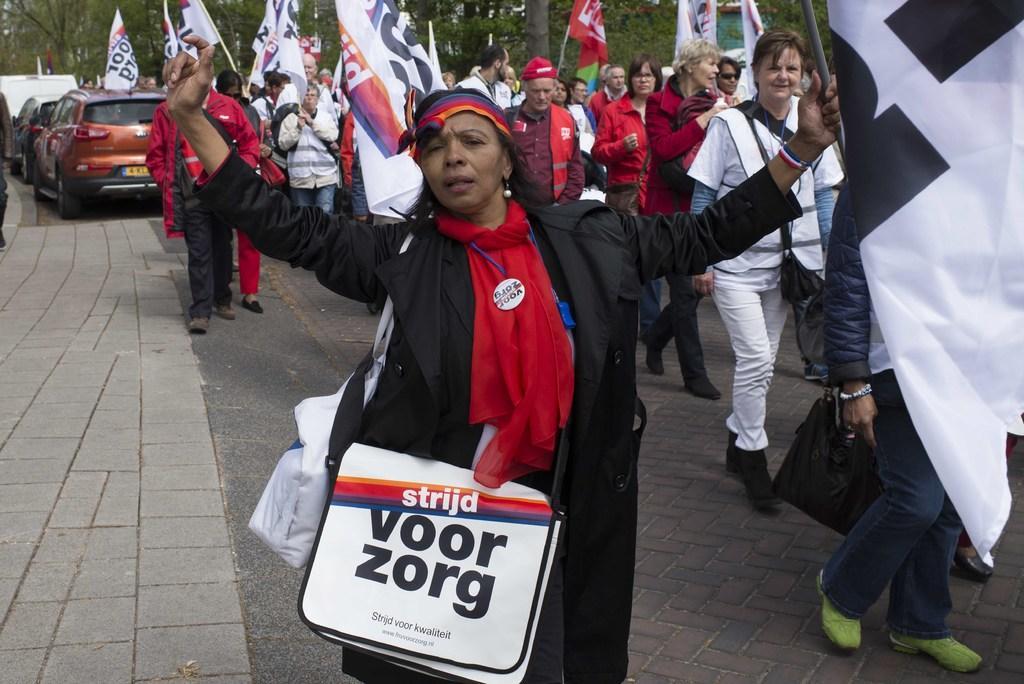Describe this image in one or two sentences. In this picture there is a lady in the center of the image, by holding a flag in her hand and there are other people those who are standing behind her, by holding flags in there hands, it seems to be a march and there are cars and trees in the background area of the image. 